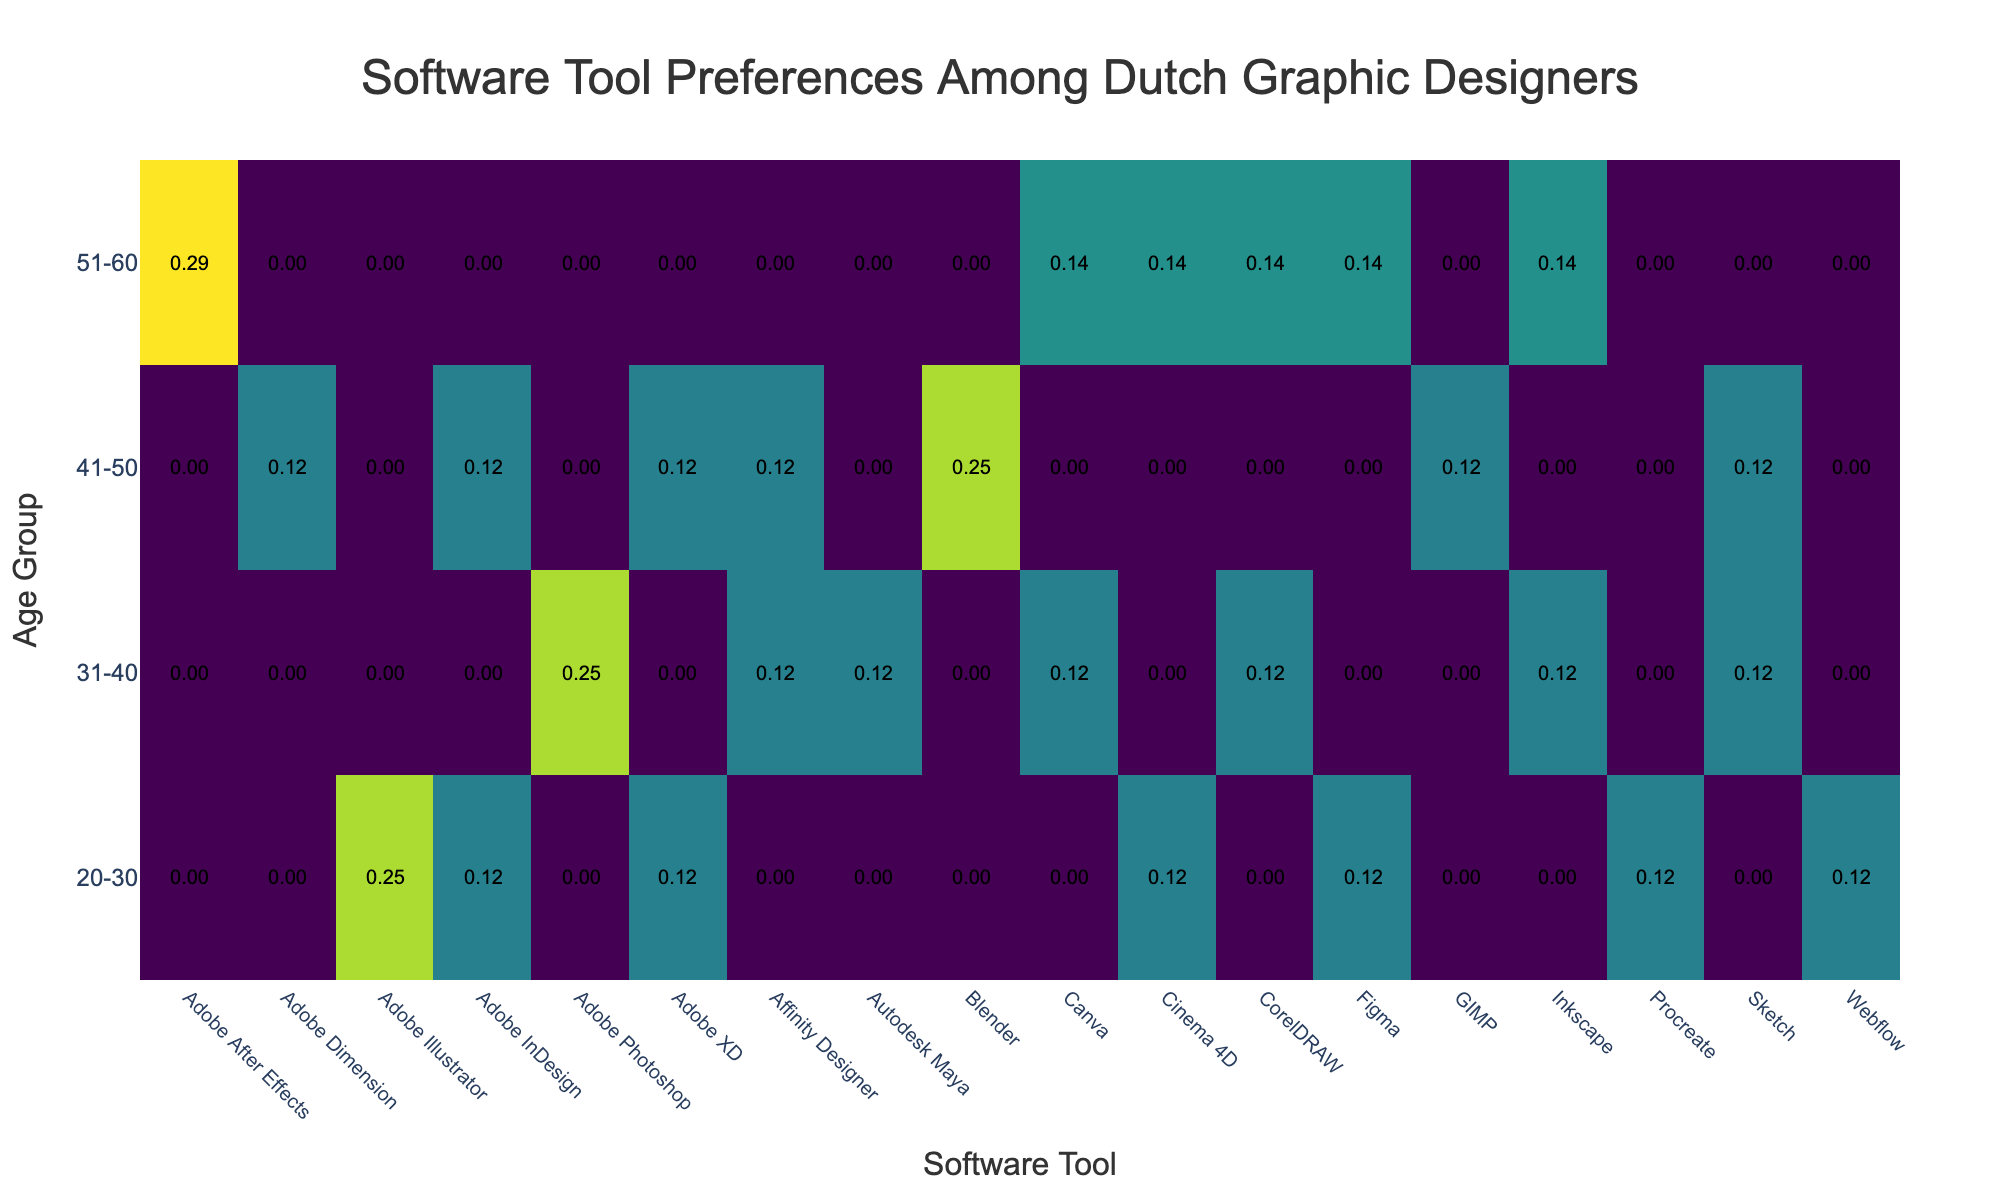What software tool is most preferred by the 31-40 age group? Looking at the table, the highest usage frequency for the 31-40 age group is with Adobe Photoshop, which has daily usage.
Answer: Adobe Photoshop Is Figma used more frequently by the 51-60 age group than Adobe Illustrator in the 20-30 age group? Figma is marked daily for the 51-60 age group, while Adobe Illustrator is used daily for the 20-30 age group but also has a weekly usage. Therefore, Figma is claimed to have a higher frequency of usage overall between the two age groups.
Answer: Yes What is the average usage frequency of software tools in the 41-50 age group? The tools used for the 41-50 age group have 3 daily usages, 5 weekly usages, and 5 monthly usages. To calculate the average, 3 + (5*0.5) + (5*1/3) = (3 + 2.5 + 1.67) / 5 = 5.17. Thus, the average frequency for the 41-50 age group is lower than other groups due to more monthly and weekly usages but no high daily frequency.
Answer: 0.54 Does any age group have more than one software tool with beginner experience level? Yes, several age groups like 41-50 have tools like CorelDRAW and Adobe Dimension categorized as beginner-level tools based on the data.
Answer: Yes Which age group shows the least diversity in software tool preferences? By reviewing the data, the 51-60 age group only uses a smaller number of tools compared to others, making it stand out with less diversity. They predominantly use Figma, Adobe After Effects, Cinema 4D, and CorelDRAW with a few entries.
Answer: 51-60 